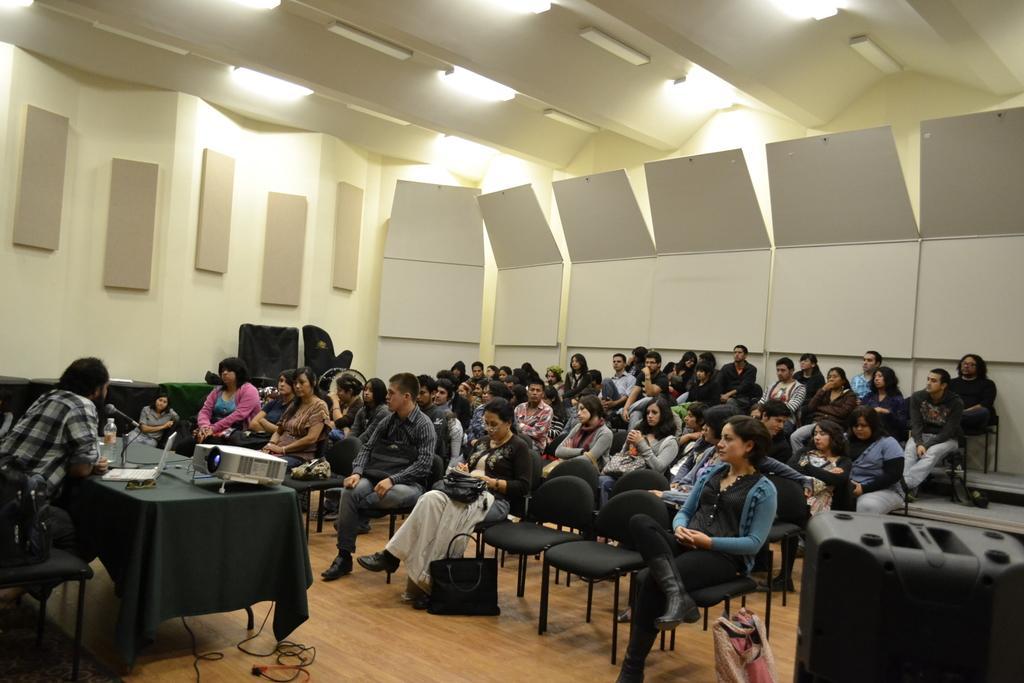In one or two sentences, can you explain what this image depicts? In this picture there are people sitting on chairs and we can see bottle, microphone, laptop and projector on the table. We can see bags on the floor. In the background of the image we can see wall, lights and objects. In the bottom right side of the image we can see black object. 